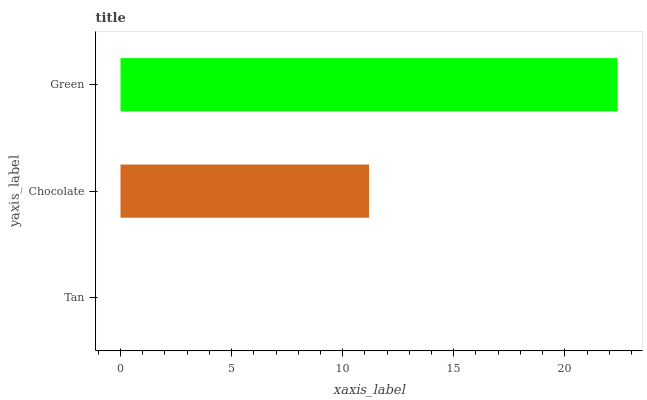Is Tan the minimum?
Answer yes or no. Yes. Is Green the maximum?
Answer yes or no. Yes. Is Chocolate the minimum?
Answer yes or no. No. Is Chocolate the maximum?
Answer yes or no. No. Is Chocolate greater than Tan?
Answer yes or no. Yes. Is Tan less than Chocolate?
Answer yes or no. Yes. Is Tan greater than Chocolate?
Answer yes or no. No. Is Chocolate less than Tan?
Answer yes or no. No. Is Chocolate the high median?
Answer yes or no. Yes. Is Chocolate the low median?
Answer yes or no. Yes. Is Green the high median?
Answer yes or no. No. Is Tan the low median?
Answer yes or no. No. 